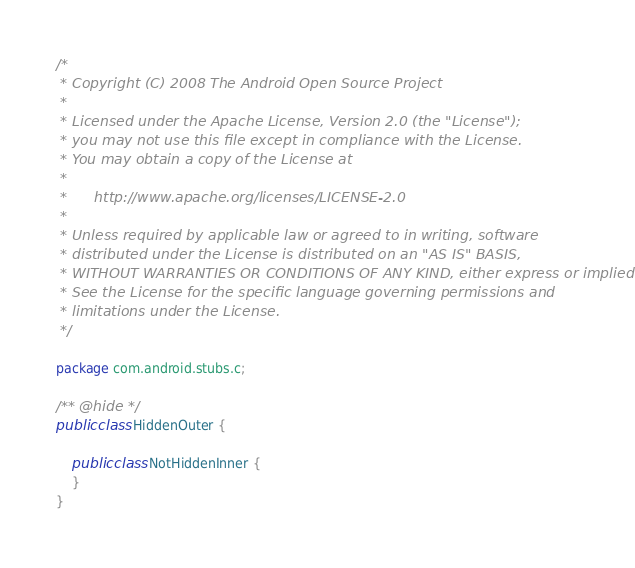<code> <loc_0><loc_0><loc_500><loc_500><_Java_>/*
 * Copyright (C) 2008 The Android Open Source Project
 *
 * Licensed under the Apache License, Version 2.0 (the "License");
 * you may not use this file except in compliance with the License.
 * You may obtain a copy of the License at
 *
 *      http://www.apache.org/licenses/LICENSE-2.0
 *
 * Unless required by applicable law or agreed to in writing, software
 * distributed under the License is distributed on an "AS IS" BASIS,
 * WITHOUT WARRANTIES OR CONDITIONS OF ANY KIND, either express or implied.
 * See the License for the specific language governing permissions and
 * limitations under the License.
 */

package com.android.stubs.c;

/** @hide */
public class HiddenOuter {

    public class NotHiddenInner {
    }
}

</code> 